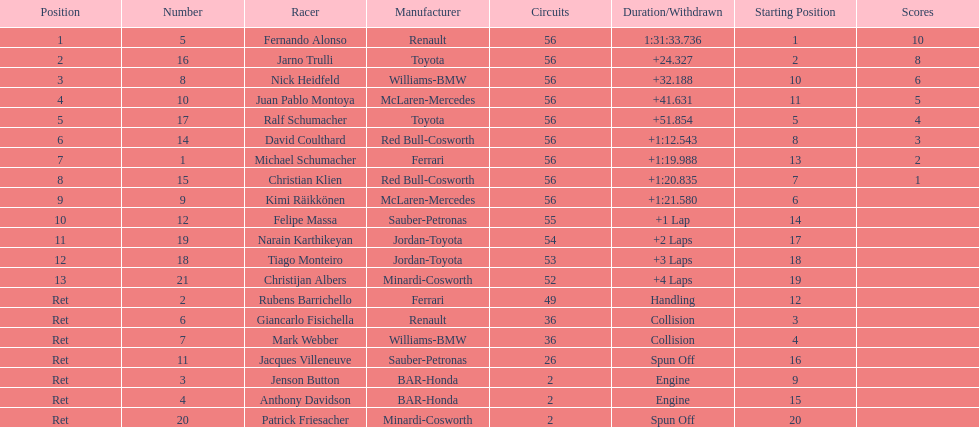How many drivers ended the race early because of engine problems? 2. 